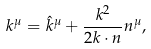Convert formula to latex. <formula><loc_0><loc_0><loc_500><loc_500>k ^ { \mu } = \hat { k } ^ { \mu } + \frac { k ^ { 2 } } { 2 k \cdot n } n ^ { \mu } ,</formula> 